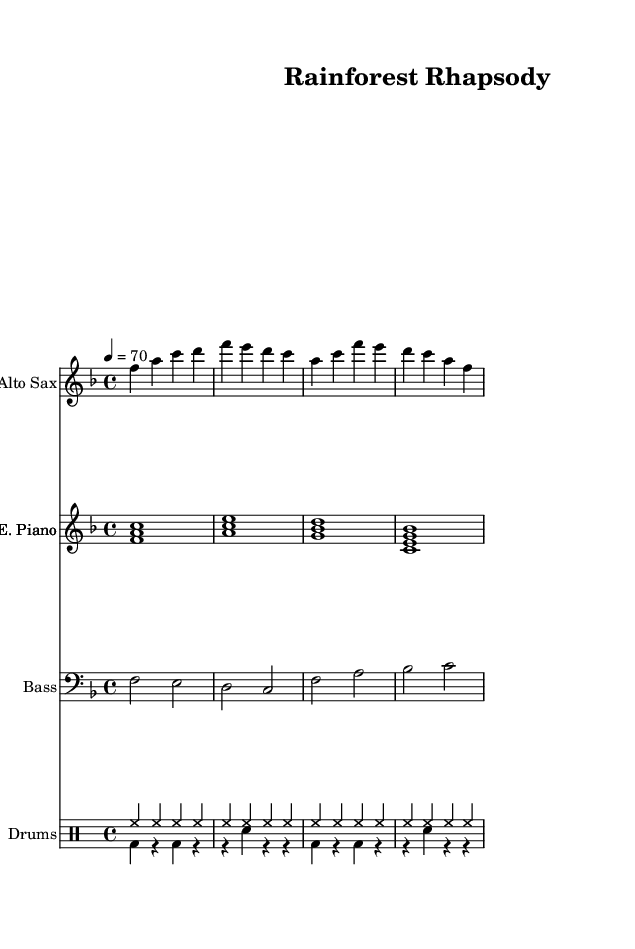What is the key signature of this music? The key signature is F major, which has one flat (B flat). This can be determined by looking at the key signature marker at the beginning of the staff, which indicates F major.
Answer: F major What is the time signature of this music? The time signature is 4/4, as indicated by the fraction at the beginning of the sheet music. This means there are four beats in each measure and the quarter note gets one beat.
Answer: 4/4 What is the tempo marking of this composition? The tempo marking is 70 beats per minute, which is indicated by the "4 = 70" above the staff. This shows how many quarter note beats there are in one minute.
Answer: 70 Which instrument is primarily playing the melody in this piece? The melody is primarily played by the Alto Saxophone, which is indicated by the instrument name at the top of the staff dedicated to that part.
Answer: Alto Saxophone How many distinct instruments are featured in this score? There are four distinct instruments featured: Alto Saxophone, Electric Piano, Bass, and Drums. This can be seen in the layout where each instrument is placed in its own staff.
Answer: Four What rhythmic pattern does the drum part primarily utilize? The drum part primarily utilizes a hi-hat rhythm played in steady quarter notes. This can be seen in the drum notation where the hi-hat is consistently marked throughout the measures.
Answer: Hi-hat rhythm What type of harmony is suggested by the chords in the Electric Piano part? The chords suggest a jazz harmony with extended tones, as the Electric Piano plays triads that include the sixth and ninth degree (such as the A-C-E chord). This reflects common jazz harmonic practices.
Answer: Jazz harmony 